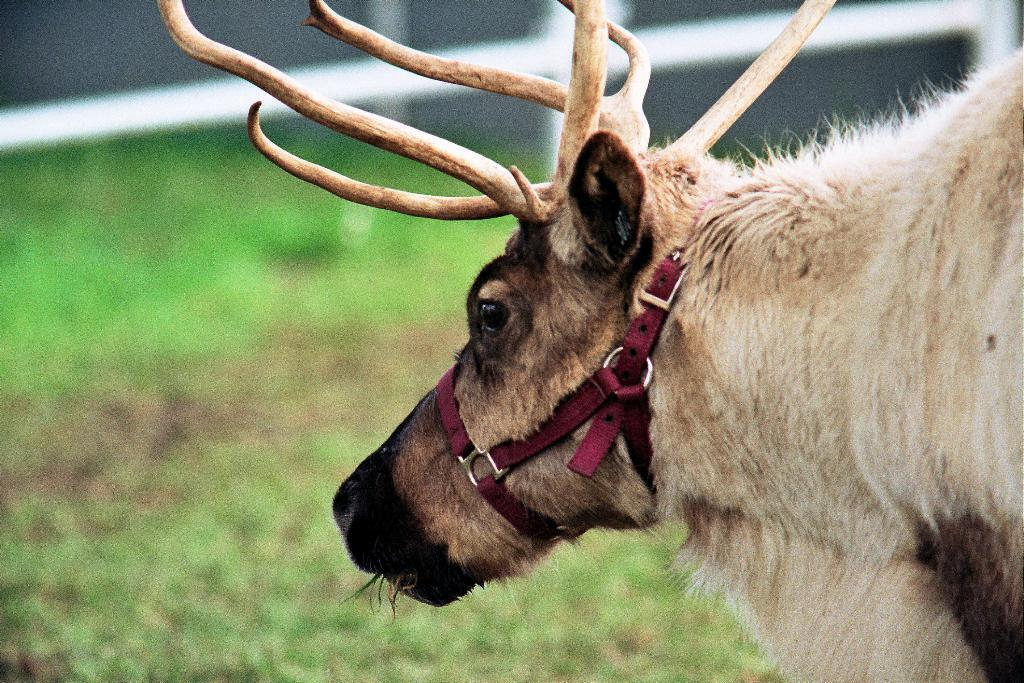What animal is present in the image? There is a moose in the image. Where is the moose located in the image? The moose is on the ground. What type of knot is the moose using to tie its shoes in the image? There is no indication in the image that the moose is wearing shoes or using a knot. 